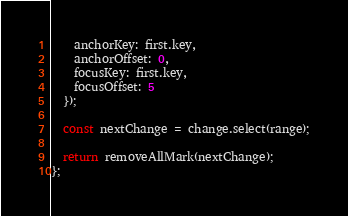<code> <loc_0><loc_0><loc_500><loc_500><_JavaScript_>    anchorKey: first.key,
    anchorOffset: 0,
    focusKey: first.key,
    focusOffset: 5
  });

  const nextChange = change.select(range);

  return removeAllMark(nextChange);
};
</code> 